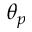Convert formula to latex. <formula><loc_0><loc_0><loc_500><loc_500>\theta _ { p }</formula> 